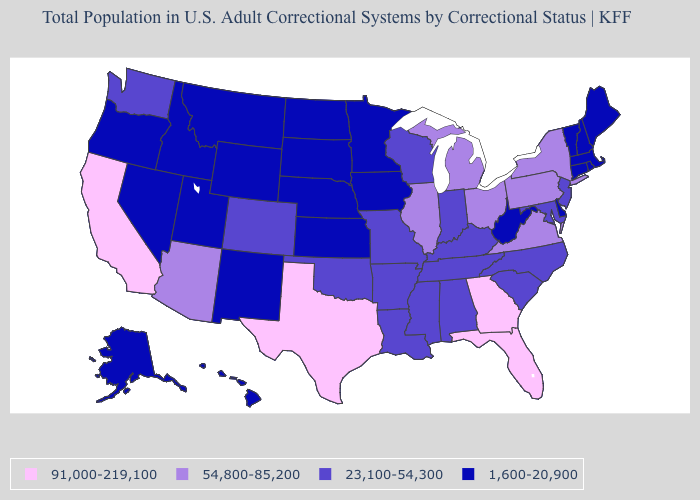Name the states that have a value in the range 91,000-219,100?
Short answer required. California, Florida, Georgia, Texas. Name the states that have a value in the range 23,100-54,300?
Keep it brief. Alabama, Arkansas, Colorado, Indiana, Kentucky, Louisiana, Maryland, Mississippi, Missouri, New Jersey, North Carolina, Oklahoma, South Carolina, Tennessee, Washington, Wisconsin. Among the states that border Virginia , does West Virginia have the lowest value?
Short answer required. Yes. Does the first symbol in the legend represent the smallest category?
Write a very short answer. No. Does Florida have the highest value in the USA?
Keep it brief. Yes. What is the value of Nevada?
Write a very short answer. 1,600-20,900. Does the map have missing data?
Answer briefly. No. Does Rhode Island have a lower value than Montana?
Answer briefly. No. Does Oregon have the highest value in the West?
Write a very short answer. No. What is the value of New Jersey?
Be succinct. 23,100-54,300. Does the map have missing data?
Keep it brief. No. Name the states that have a value in the range 91,000-219,100?
Short answer required. California, Florida, Georgia, Texas. Among the states that border Virginia , which have the lowest value?
Write a very short answer. West Virginia. Does the map have missing data?
Quick response, please. No. What is the value of Hawaii?
Keep it brief. 1,600-20,900. 